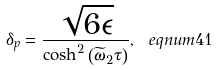<formula> <loc_0><loc_0><loc_500><loc_500>\delta _ { p } = \frac { \sqrt { 6 \epsilon } } { \cosh ^ { 2 } \left ( \widetilde { \omega } _ { 2 } \tau \right ) } , \ e q n u m { 4 1 }</formula> 